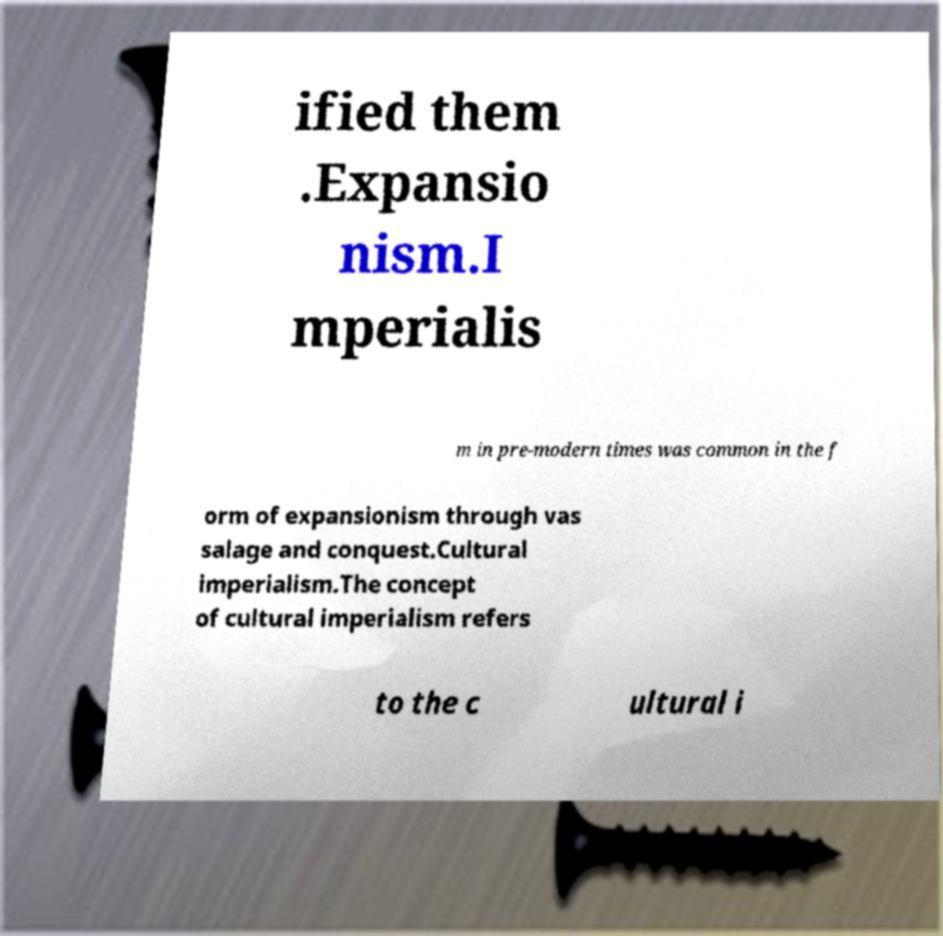Could you extract and type out the text from this image? ified them .Expansio nism.I mperialis m in pre-modern times was common in the f orm of expansionism through vas salage and conquest.Cultural imperialism.The concept of cultural imperialism refers to the c ultural i 